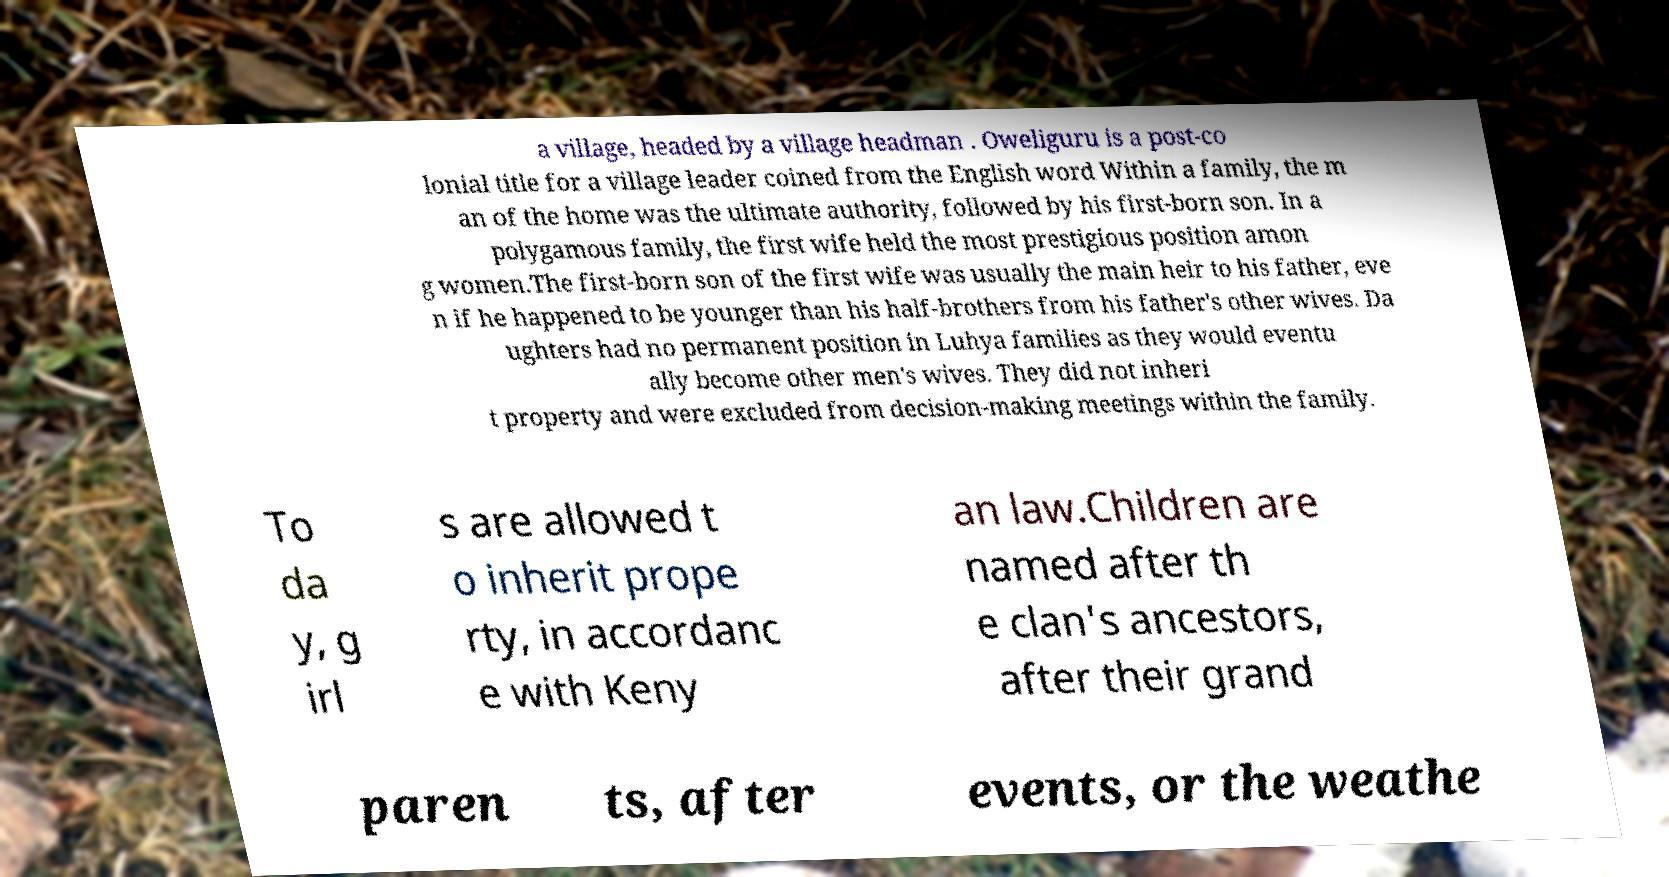What messages or text are displayed in this image? I need them in a readable, typed format. a village, headed by a village headman . Oweliguru is a post-co lonial title for a village leader coined from the English word Within a family, the m an of the home was the ultimate authority, followed by his first-born son. In a polygamous family, the first wife held the most prestigious position amon g women.The first-born son of the first wife was usually the main heir to his father, eve n if he happened to be younger than his half-brothers from his father's other wives. Da ughters had no permanent position in Luhya families as they would eventu ally become other men's wives. They did not inheri t property and were excluded from decision-making meetings within the family. To da y, g irl s are allowed t o inherit prope rty, in accordanc e with Keny an law.Children are named after th e clan's ancestors, after their grand paren ts, after events, or the weathe 